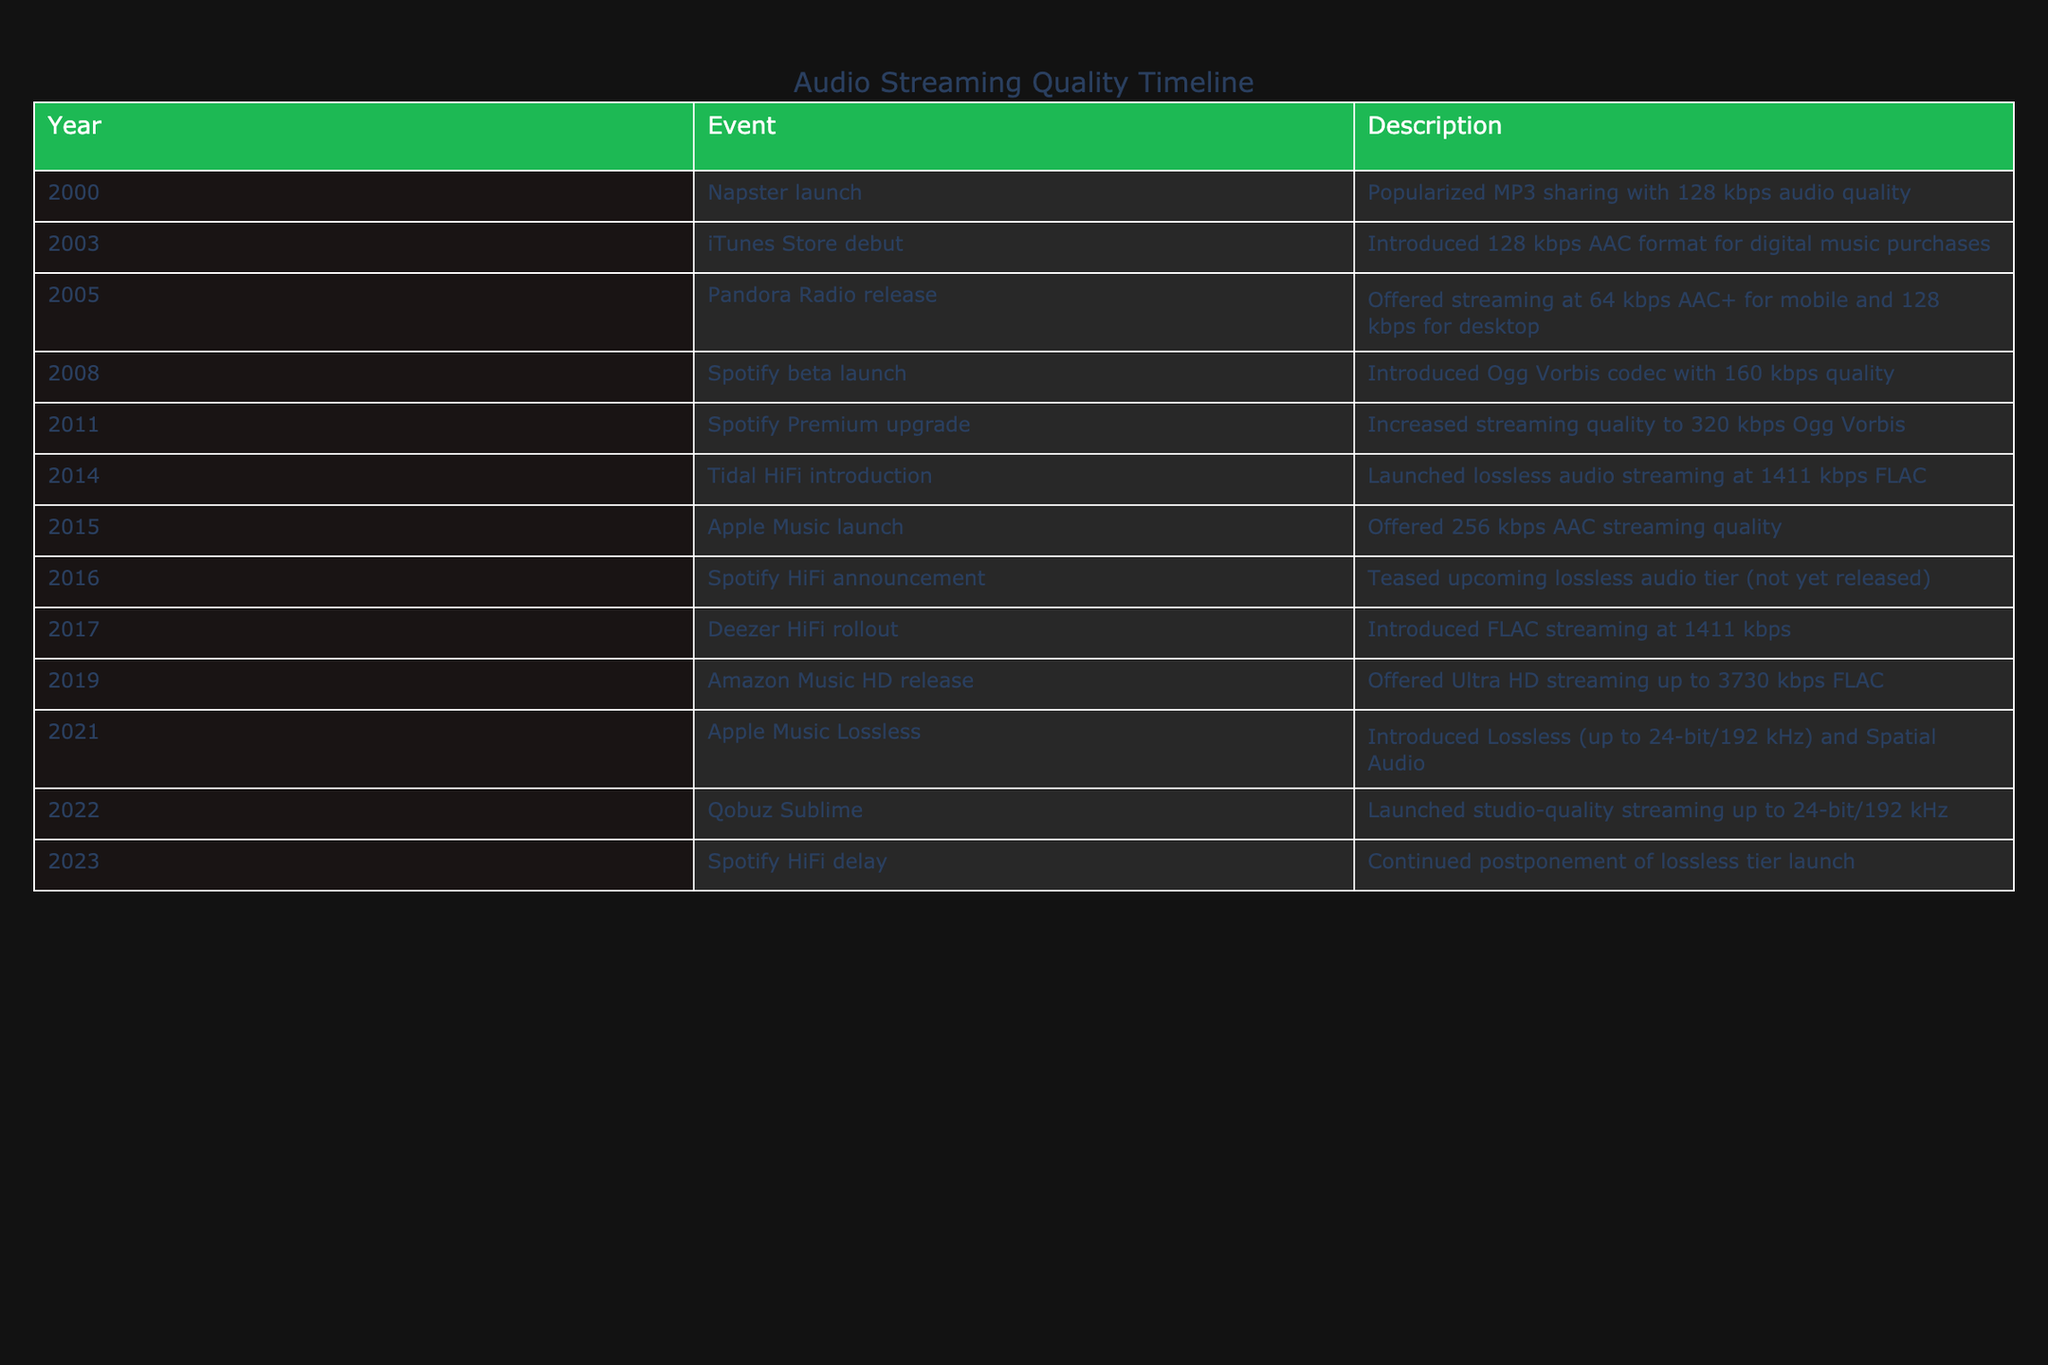What was the audio quality of Napster at its launch in 2000? The table states that Napster popularized MP3 sharing with an audio quality of 128 kbps in the year 2000. Therefore, the audio quality at its launch is directly listed in the table.
Answer: 128 kbps Which streaming service first offered lossless audio streaming? The table identifies Tidal HiFi introduction in 2014 as the first service to launch lossless audio streaming at 1411 kbps FLAC. This is explicitly noted in the description for that year.
Answer: Tidal HiFi What is the difference in audio quality between Spotify Premium in 2011 and Amazon Music HD in 2019? Spotify Premium increased streaming quality to 320 kbps in 2011, whereas Amazon Music HD offered Ultra HD streaming up to 3730 kbps in 2019. The difference is calculated as 3730 kbps - 320 kbps = 3410 kbps.
Answer: 3410 kbps Did Apple Music launch before or after Spotify? Apple Music launched in 2015 while Spotify beta launched in 2008, indicating that Apple Music was introduced after Spotify. This can be inferred by comparing the years listed in the table.
Answer: After What was the audio quality trend observed from 2000 to 2023? Analyzing the years and their specific audio qualities listed, there is a noticeable trend of increasing audio quality from 128 kbps in 2000 to up to 3730 kbps in 2019. This reflects a broader evolution in technology and streaming capabilities over the years.
Answer: Increasing What was the highest audio quality reported in the table, and in which year was it introduced? The highest audio quality reported in the table is 3730 kbps FLAC, which was introduced in 2019 with Amazon Music HD. The comparison of all years shows that this value is the maximum among all entries.
Answer: 3730 kbps in 2019 Were there any audio quality tiers announced for Spotify in both 2016 and 2023? The table indicates that Spotify announced a HiFi tier in 2016 but did not successfully launch it as of 2023. This means there was an announcement for a premium tier but ultimately not realized by the noted date.
Answer: Yes What are the audio qualities introduced in lossless streaming services from Tidal HiFi to Qobuz Sublime? From the table, Tidal HiFi offered 1411 kbps in 2014, and Qobuz Sublime later launched studio-quality streaming up to 24-bit/192 kHz in 2022. Thus, both provide high-quality lossless options, but the actual numerical comparison of quality is not directly stated for Qobuz Sublime.
Answer: 1411 kbps (Tidal) and up to 24-bit/192 kHz (Qobuz) 